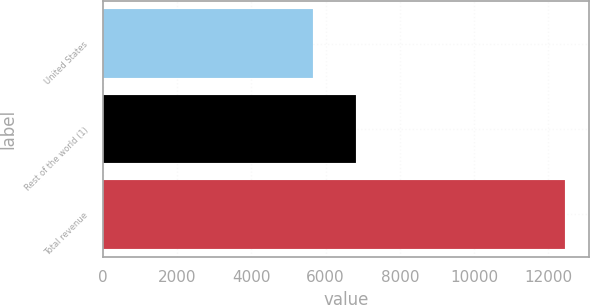<chart> <loc_0><loc_0><loc_500><loc_500><bar_chart><fcel>United States<fcel>Rest of the world (1)<fcel>Total revenue<nl><fcel>5649<fcel>6817<fcel>12466<nl></chart> 